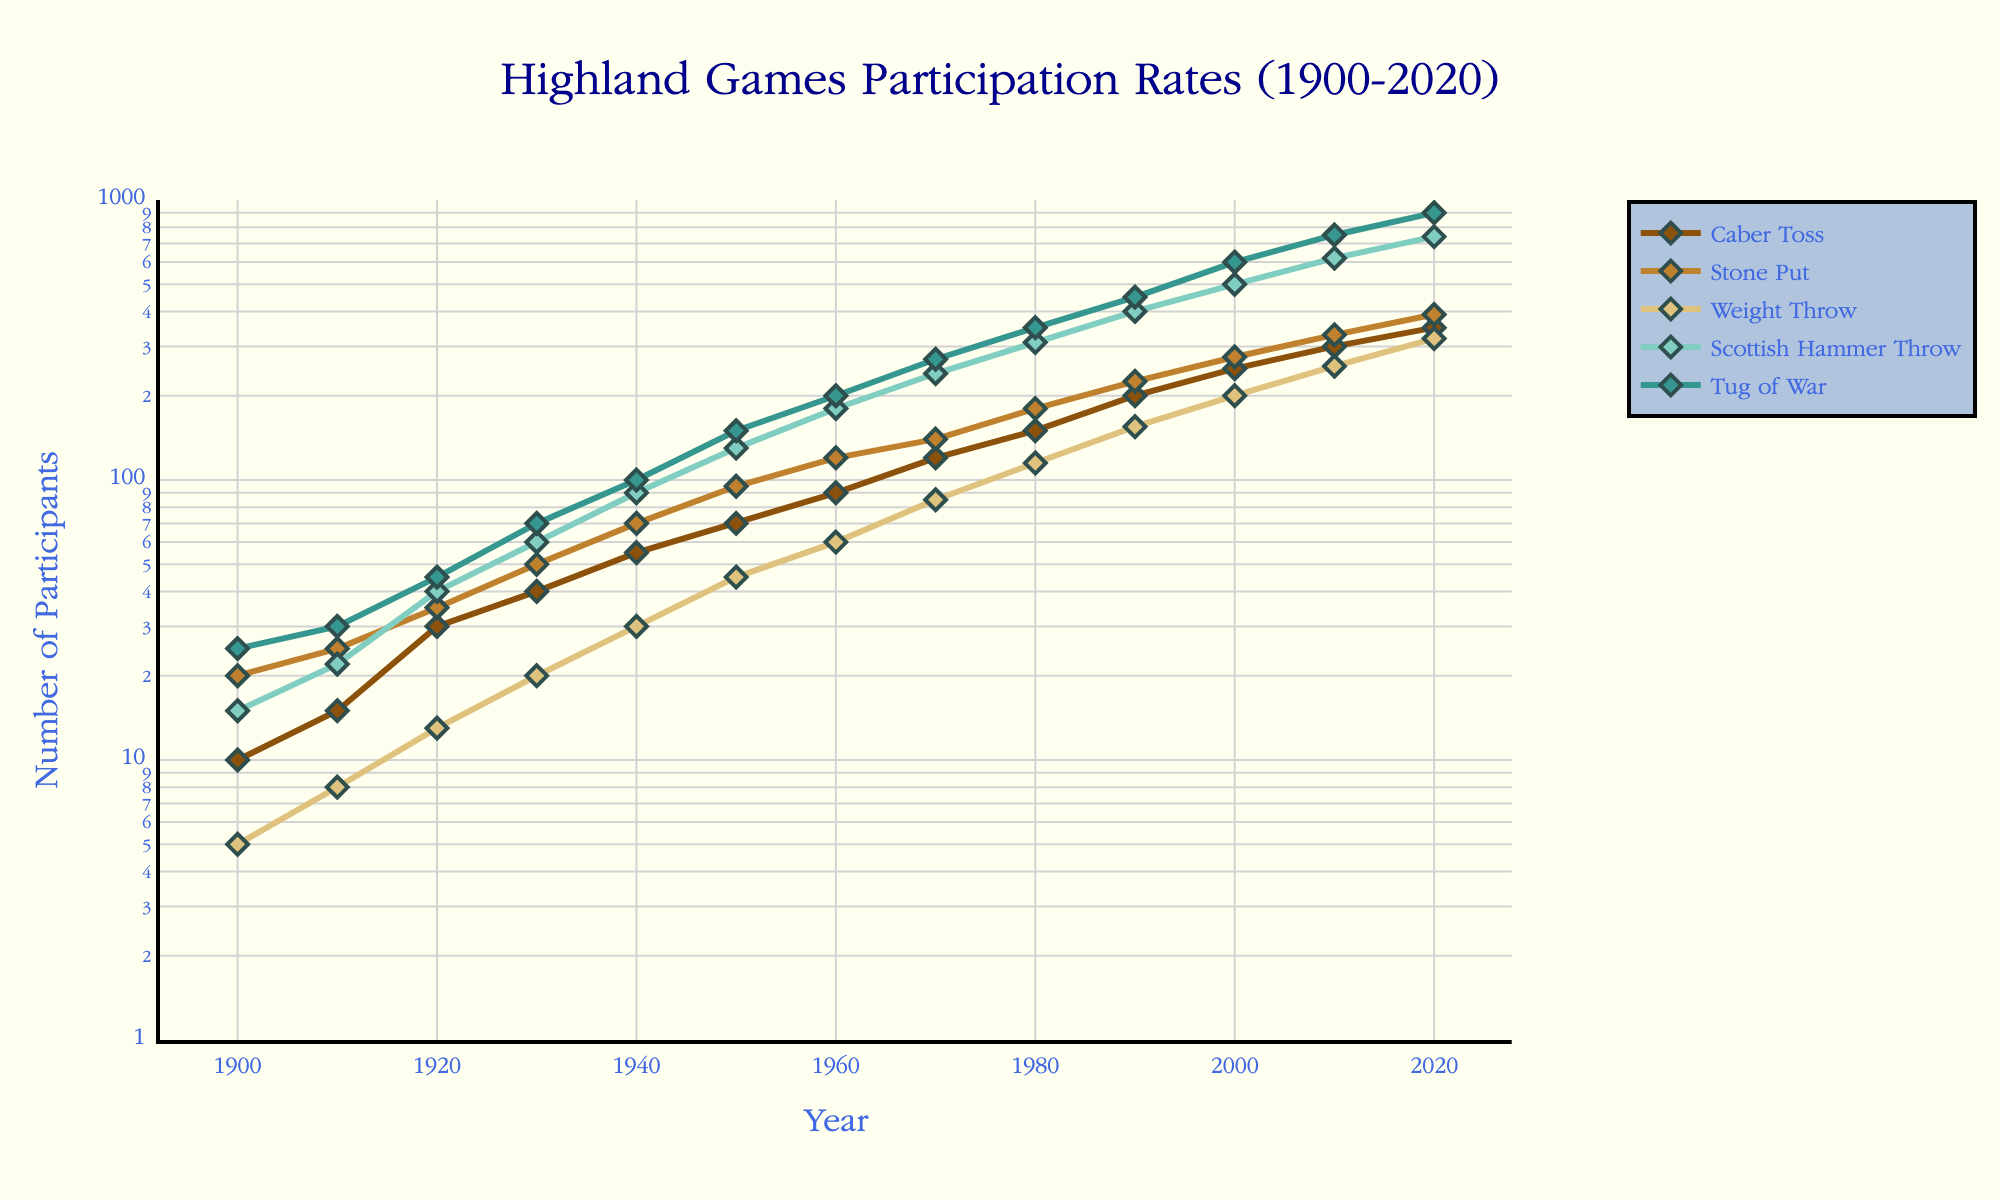What is the overall trend for the Caber Toss event from 1900 to 2020? The line plot shows the Caber Toss participation rates increasing over time. Starting at 10 participants in 1900, it consistently rises to 350 in 2020. The log scale indicates exponential growth.
Answer: Increasing Which event had the highest number of participants in 2020? By observing the plotted lines and markers at 2020, the Tug of War event reaches 900 participants, the highest among all events.
Answer: Tug of War How does the growth rate of the Tug of War compare to the Caber Toss from 1900 to 2020? On the log scale plot, both events show exponential growth, but the Tug of War starts higher and ends significantly higher. From 25 participants in 1900 to 900 in 2020, while Caber Toss starts at 10 and ends at 350. Therefore, the rate of increase is faster for the Tug of War.
Answer: Faster for Tug of War What is the average number of participants for the Weight Throw event in the years 1900, 1950, and 2000? First, locate the values for 1900 (5), 1950 (45), and 2000 (200). Sum these values (5 + 45 + 200 = 250) and divide by 3 to get the average: 250 / 3 ≈ 83.33.
Answer: 83.33 Which event shows the least amount of participation growth over the entire period? By comparing the slope and change in the lines on the log plot, the Weight Throw shows the least absolute change. It starts at 5 in 1900 and increases to 320 in 2020, a smaller rate of change compared to other events.
Answer: Weight Throw Between the years 1900 and 1950, which event had the greatest increase in the number of participants? For each event, determine the difference in participants between 1950 and 1900: Caber Toss (70-10 = 60), Stone Put (95-20 = 75), Weight Throw (45-5 = 40), Scottish Hammer Throw (130-15 = 115), and Tug of War (150-25 = 125). The greatest increase is in the Tug of War.
Answer: Tug of War What event had the closest number of participants in both 1920 and 2020? Locate the values for each event in 1920 and 2020: Caber Toss (30, 350), Stone Put (35, 390), Weight Throw (13, 320), Scottish Hammer Throw (40, 740), and Tug of War (45, 900). Compute the differences: Caber Toss (320), Stone Put (355), etc., and the Weight Throw shows the closest numbers with a difference of 307.
Answer: Weight Throw At what year did the Scottish Hammer Throw reach 310 participants? Trace the markers along the Scottish Hammer Throw line until it intersects at 310 participants; this occurs around the year 1980.
Answer: 1980 